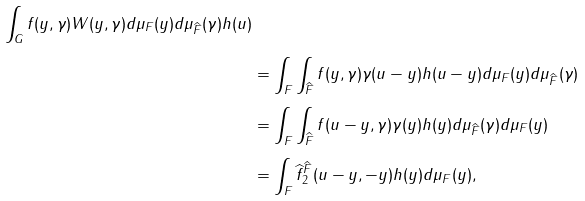<formula> <loc_0><loc_0><loc_500><loc_500>{ \int _ { G } f ( y , \gamma ) W ( y , \gamma ) d \mu _ { F } ( y ) d \mu _ { \widehat { F } } ( \gamma ) h ( u ) } \\ & = \int _ { F } \int _ { \widehat { F } } f ( y , \gamma ) \gamma ( u - y ) h ( u - y ) d \mu _ { F } ( y ) d \mu _ { \widehat { F } } ( \gamma ) \\ & = \int _ { F } \int _ { \widehat { F } } f ( u - y , \gamma ) \gamma ( y ) h ( y ) d \mu _ { \widehat { F } } ( \gamma ) d \mu _ { F } ( y ) \\ & = \int _ { F } \widehat { f } ^ { \widehat { F } } _ { 2 } ( u - y , - y ) h ( y ) d \mu _ { F } ( y ) ,</formula> 